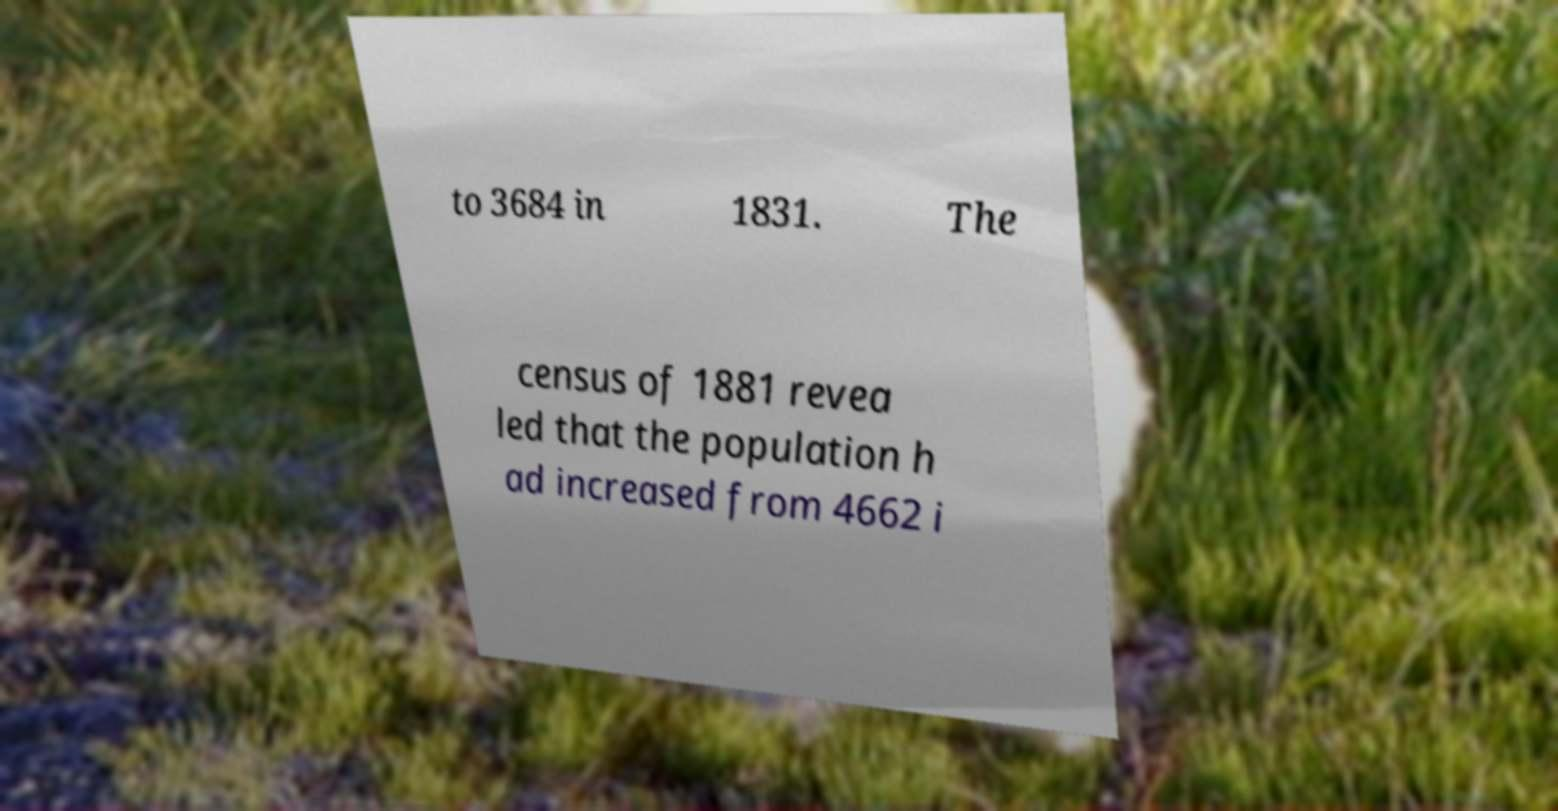Please identify and transcribe the text found in this image. to 3684 in 1831. The census of 1881 revea led that the population h ad increased from 4662 i 